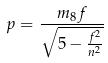Convert formula to latex. <formula><loc_0><loc_0><loc_500><loc_500>p = \frac { m _ { 8 } f } { \sqrt { 5 - \frac { f ^ { 2 } } { n ^ { 2 } } } }</formula> 